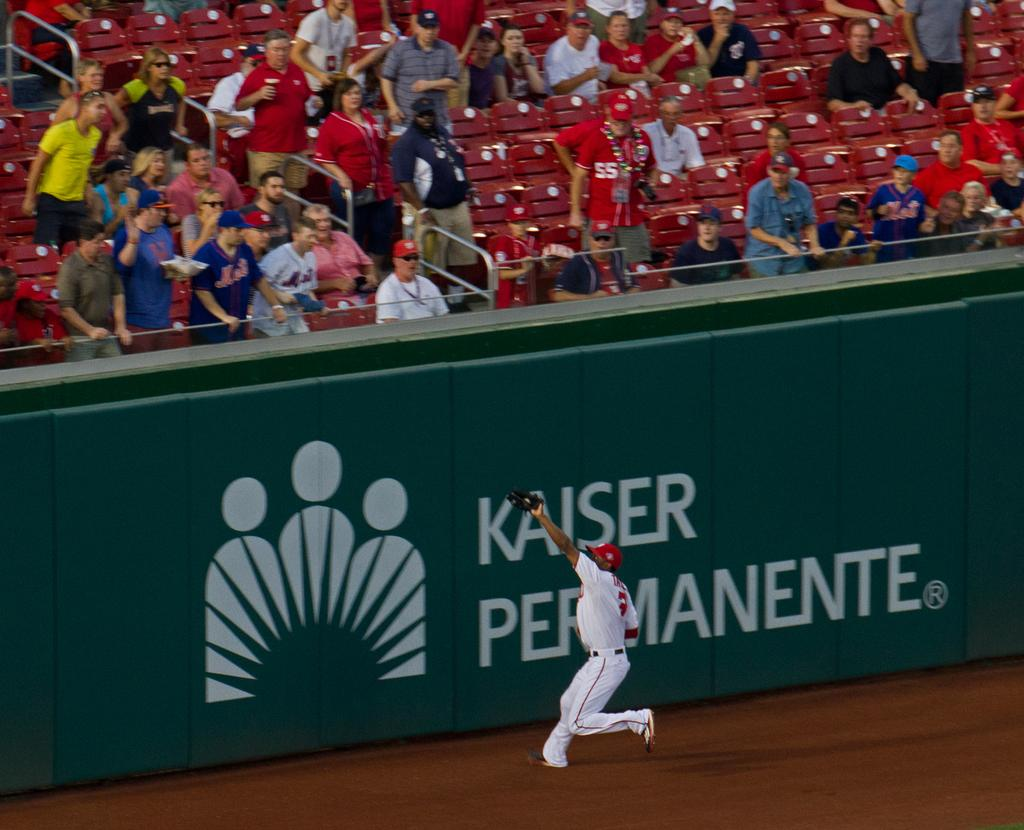<image>
Offer a succinct explanation of the picture presented. A baseball player tries to catch a ball in front of a green Kaiser Permanente sign. 